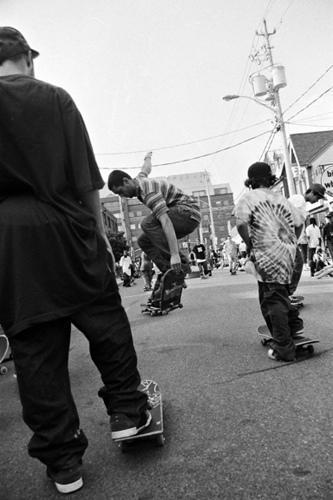How many of them are wearing baseball caps?
Give a very brief answer. 2. How many people are there?
Give a very brief answer. 3. 